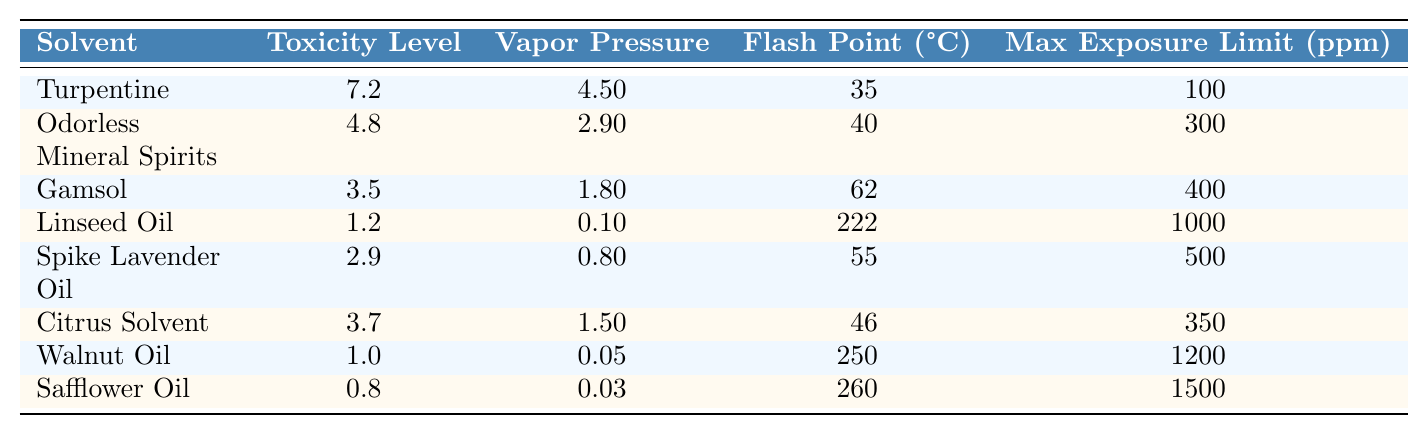What is the toxicity level of Turpentine? The table lists the toxicity level of Turpentine as 7.2.
Answer: 7.2 Which solvent has the highest flash point? Linseed Oil has a flash point of 222, which is the highest among all listed solvents.
Answer: 222 Is the toxicity level of Gamsol lower than that of Citrus Solvent? Gamsol has a toxicity level of 3.5, while Citrus Solvent has a toxicity level of 3.7, which means Gamsol's toxicity level is lower.
Answer: Yes What is the average toxicity level of all solvents listed in the table? The total toxicity levels are 7.2 + 4.8 + 3.5 + 1.2 + 2.9 + 3.7 + 1.0 + 0.8 = 25.3. There are 8 solvents, so the average is 25.3 / 8 = 3.1625, which can be rounded to 3.2.
Answer: 3.2 Which solvent has the lowest maximum exposure limit? Walnut Oil has the lowest maximum exposure limit of 1200 ppm compared to the others.
Answer: 1200 What are the toxicity levels of Linseed Oil and Safflower Oil combined? Linseed Oil has a toxicity level of 1.2, and Safflower Oil has a toxicity level of 0.8, so combined they sum up to 1.2 + 0.8 = 2.0.
Answer: 2.0 Is it true that Odorless Mineral Spirits has a higher vapor pressure than Gamsol? The vapor pressure of Odorless Mineral Spirits is 2.9, while Gamsol's vapor pressure is 1.8, confirming that Odorless Mineral Spirits has a higher vapor pressure.
Answer: Yes Which solvent(s) have a toxicity level less than 2? Linseed Oil (1.2), Walnut Oil (1.0), and Safflower Oil (0.8) all have a toxicity level less than 2.
Answer: Linseed Oil, Walnut Oil, Safflower Oil If a painter was exposed to the maximum limit of both Turpentine and Spike Lavender Oil, what would the total exposure level be? The maximum exposure limit for Turpentine is 100 ppm, and for Spike Lavender Oil, it is 500 ppm. The total would be 100 + 500 = 600 ppm.
Answer: 600 What is the difference in toxicity levels between the most toxic (Turpentine) and the least toxic solvent (Safflower Oil)? Turpentine has a toxicity level of 7.2, and Safflower Oil has a toxicity level of 0.8. The difference is 7.2 - 0.8 = 6.4.
Answer: 6.4 